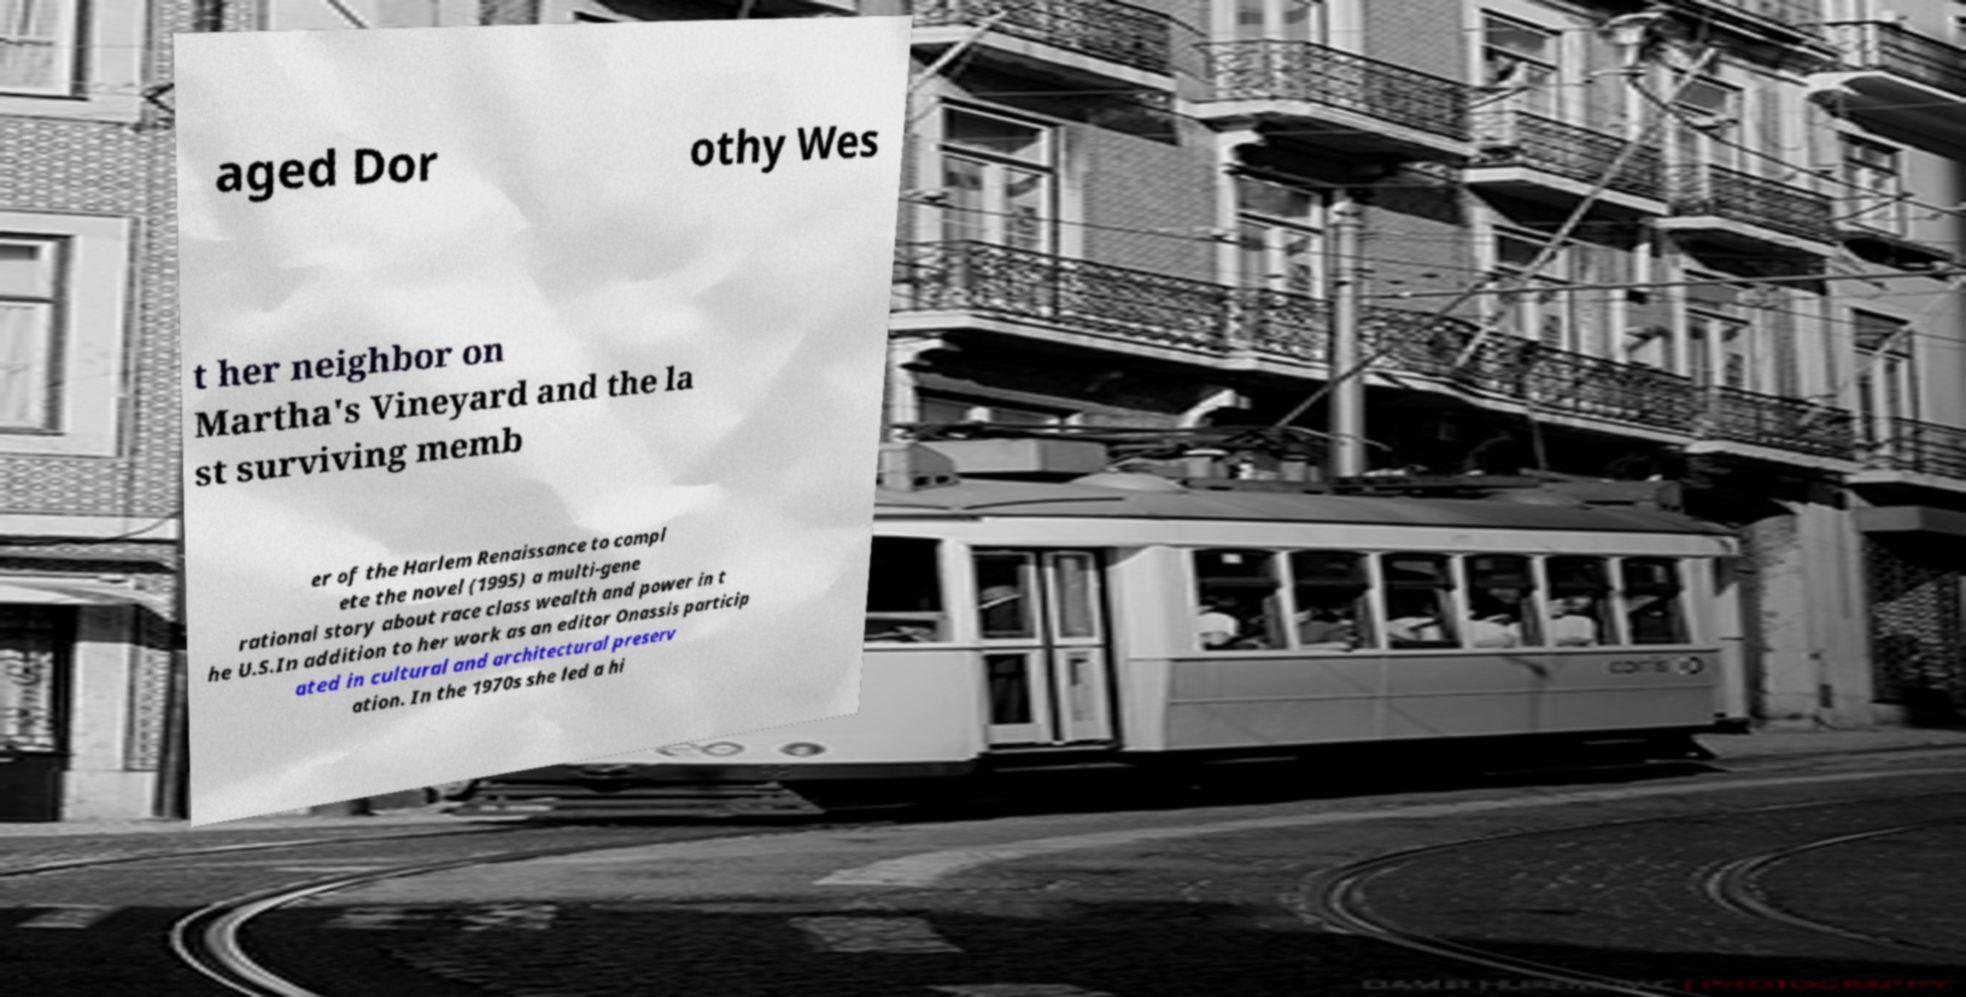Can you read and provide the text displayed in the image?This photo seems to have some interesting text. Can you extract and type it out for me? aged Dor othy Wes t her neighbor on Martha's Vineyard and the la st surviving memb er of the Harlem Renaissance to compl ete the novel (1995) a multi-gene rational story about race class wealth and power in t he U.S.In addition to her work as an editor Onassis particip ated in cultural and architectural preserv ation. In the 1970s she led a hi 